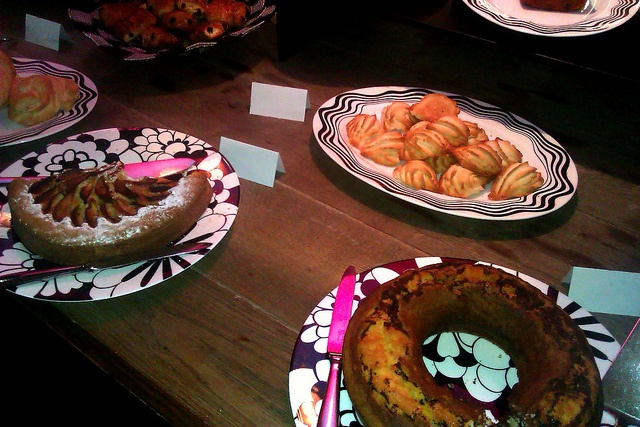Describe the objects in this image and their specific colors. I can see dining table in black, maroon, and brown tones, cake in black, maroon, brown, and olive tones, cake in black, maroon, olive, and darkgray tones, bowl in black, maroon, and gray tones, and bowl in black, pink, maroon, and lightpink tones in this image. 